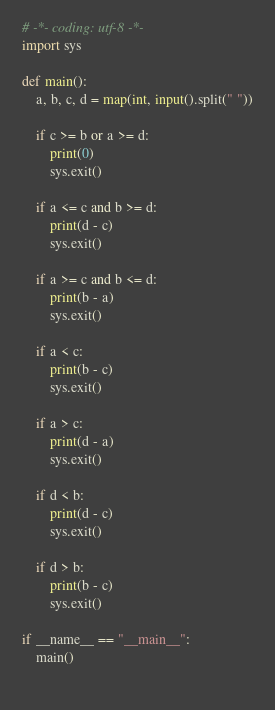<code> <loc_0><loc_0><loc_500><loc_500><_Python_># -*- coding: utf-8 -*-
import sys

def main():
	a, b, c, d = map(int, input().split(" "))
	
	if c >= b or a >= d:
		print(0)
		sys.exit()
	
	if a <= c and b >= d:
		print(d - c)
		sys.exit()
	
	if a >= c and b <= d:
		print(b - a)
		sys.exit()
		
	if a < c:
		print(b - c)
		sys.exit()
		
	if a > c:
		print(d - a)
		sys.exit()
		
	if d < b:
		print(d - c)
		sys.exit()
		
	if d > b:
		print(b - c)
		sys.exit()
	
if __name__ == "__main__":
	main()
	</code> 